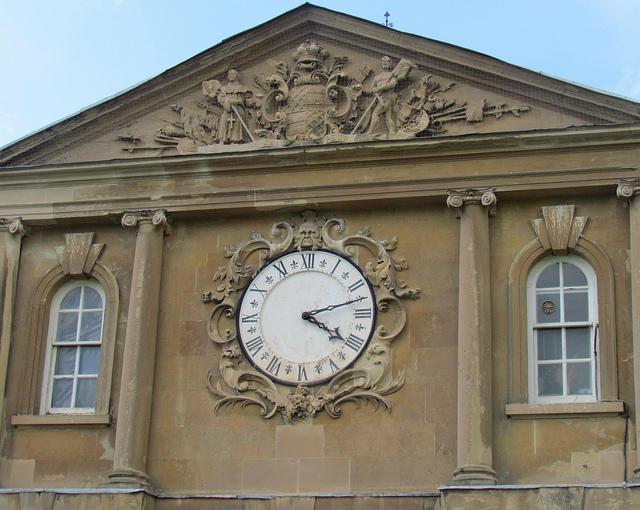What time does the clock have?
Be succinct. 4:13. What color is the building?
Keep it brief. Brown. How many windows are visible?
Write a very short answer. 2. 